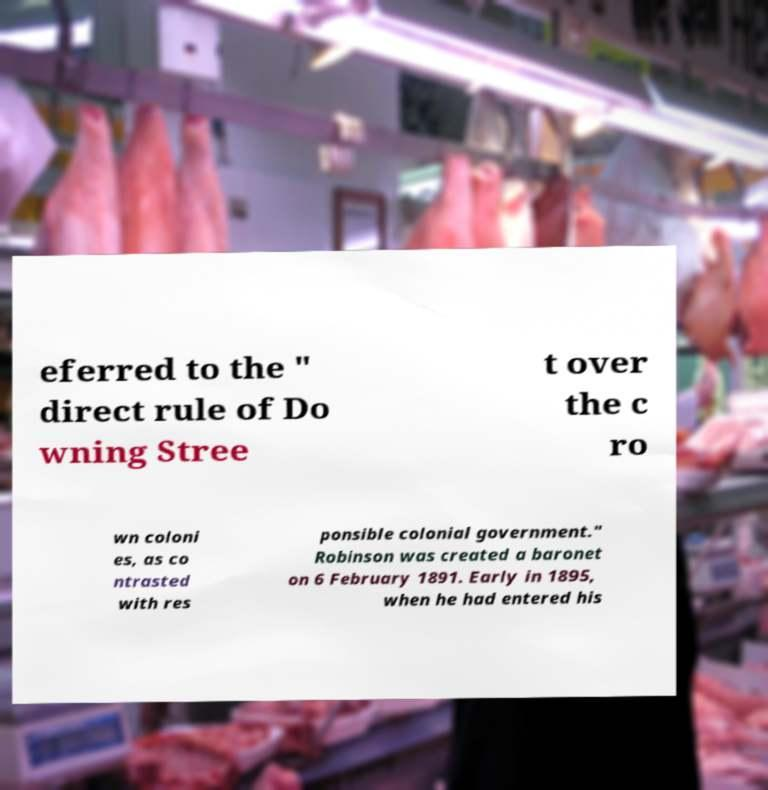What messages or text are displayed in this image? I need them in a readable, typed format. eferred to the " direct rule of Do wning Stree t over the c ro wn coloni es, as co ntrasted with res ponsible colonial government." Robinson was created a baronet on 6 February 1891. Early in 1895, when he had entered his 